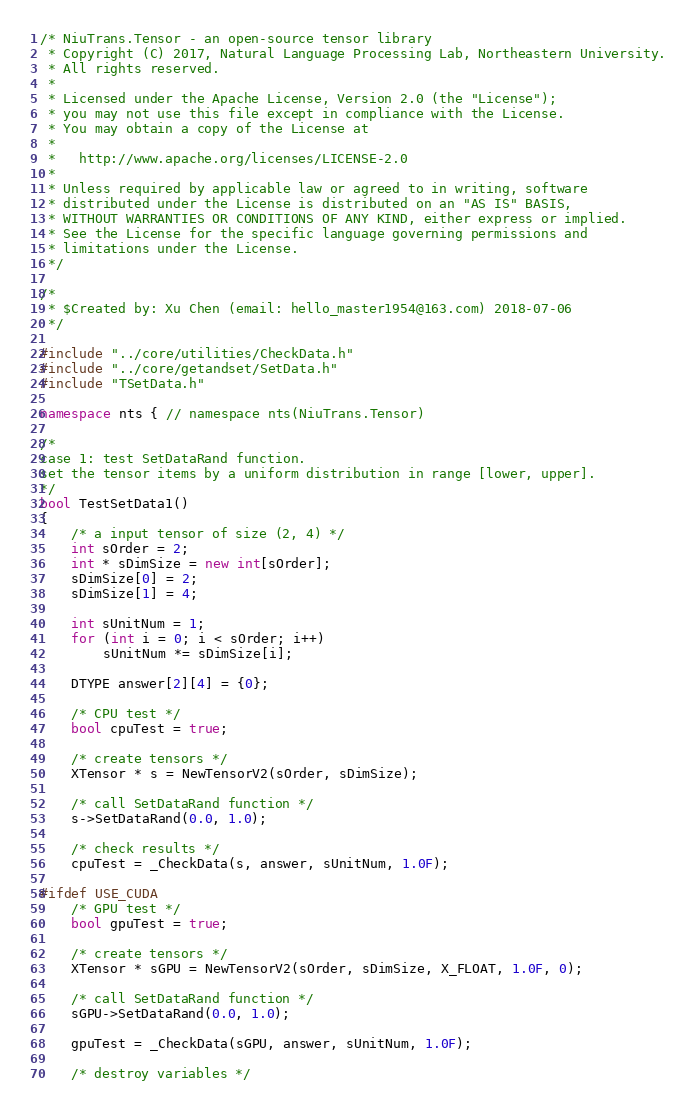<code> <loc_0><loc_0><loc_500><loc_500><_C++_>/* NiuTrans.Tensor - an open-source tensor library
 * Copyright (C) 2017, Natural Language Processing Lab, Northeastern University.
 * All rights reserved.
 *
 * Licensed under the Apache License, Version 2.0 (the "License");
 * you may not use this file except in compliance with the License.
 * You may obtain a copy of the License at
 *
 *   http://www.apache.org/licenses/LICENSE-2.0
 *
 * Unless required by applicable law or agreed to in writing, software
 * distributed under the License is distributed on an "AS IS" BASIS,
 * WITHOUT WARRANTIES OR CONDITIONS OF ANY KIND, either express or implied.
 * See the License for the specific language governing permissions and
 * limitations under the License.
 */

/*
 * $Created by: Xu Chen (email: hello_master1954@163.com) 2018-07-06
 */

#include "../core/utilities/CheckData.h"
#include "../core/getandset/SetData.h"
#include "TSetData.h"

namespace nts { // namespace nts(NiuTrans.Tensor)

/* 
case 1: test SetDataRand function.
set the tensor items by a uniform distribution in range [lower, upper]. 
*/
bool TestSetData1()
{
    /* a input tensor of size (2, 4) */
    int sOrder = 2;
    int * sDimSize = new int[sOrder];
    sDimSize[0] = 2;
    sDimSize[1] = 4;

    int sUnitNum = 1;
    for (int i = 0; i < sOrder; i++)
        sUnitNum *= sDimSize[i];

    DTYPE answer[2][4] = {0};

    /* CPU test */
    bool cpuTest = true;

    /* create tensors */
    XTensor * s = NewTensorV2(sOrder, sDimSize);

    /* call SetDataRand function */
    s->SetDataRand(0.0, 1.0);
    
    /* check results */
    cpuTest = _CheckData(s, answer, sUnitNum, 1.0F);

#ifdef USE_CUDA
    /* GPU test */
    bool gpuTest = true;

    /* create tensors */
    XTensor * sGPU = NewTensorV2(sOrder, sDimSize, X_FLOAT, 1.0F, 0);

    /* call SetDataRand function */
    sGPU->SetDataRand(0.0, 1.0);
    
    gpuTest = _CheckData(sGPU, answer, sUnitNum, 1.0F);

    /* destroy variables */</code> 